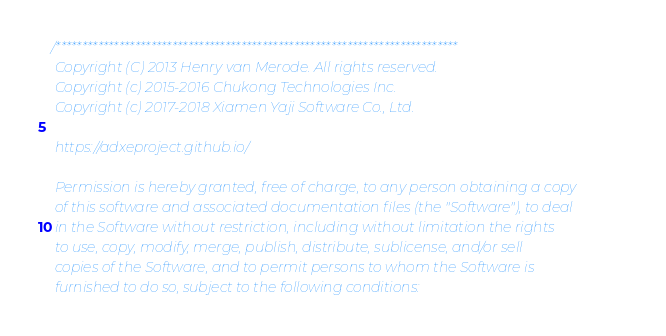<code> <loc_0><loc_0><loc_500><loc_500><_C++_>/****************************************************************************
 Copyright (C) 2013 Henry van Merode. All rights reserved.
 Copyright (c) 2015-2016 Chukong Technologies Inc.
 Copyright (c) 2017-2018 Xiamen Yaji Software Co., Ltd.

 https://adxeproject.github.io/

 Permission is hereby granted, free of charge, to any person obtaining a copy
 of this software and associated documentation files (the "Software"), to deal
 in the Software without restriction, including without limitation the rights
 to use, copy, modify, merge, publish, distribute, sublicense, and/or sell
 copies of the Software, and to permit persons to whom the Software is
 furnished to do so, subject to the following conditions:
</code> 